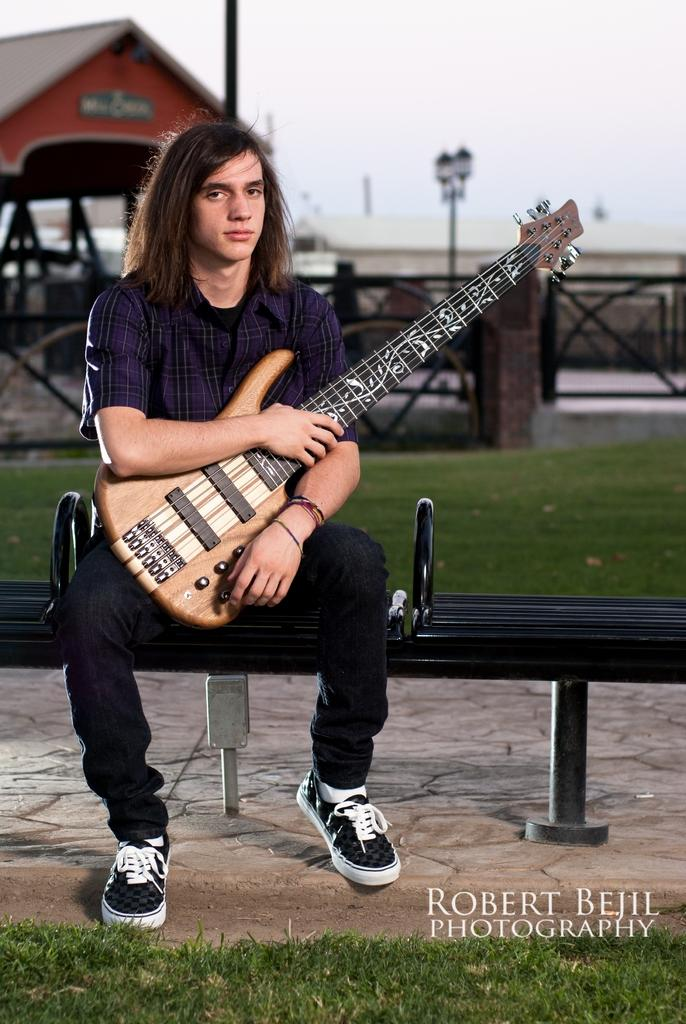What is the man in the image wearing? The man is wearing a blue shirt and black jeans. What is the man holding in the image? The man is holding a guitar. What is the man's position in the image? The man is sitting on a chair. What can be seen in the background of the image? There is a house and grills in the background of the image. What type of surface is under the man's feet in the image? There is grass on the floor in the image. What songs is the man singing in the image? The image does not show the man singing, so it cannot be determined which songs he might be singing. How many houses are visible in the image? There is only one house visible in the image. Is there a bridge present in the image? No, there is no bridge present in the image. 